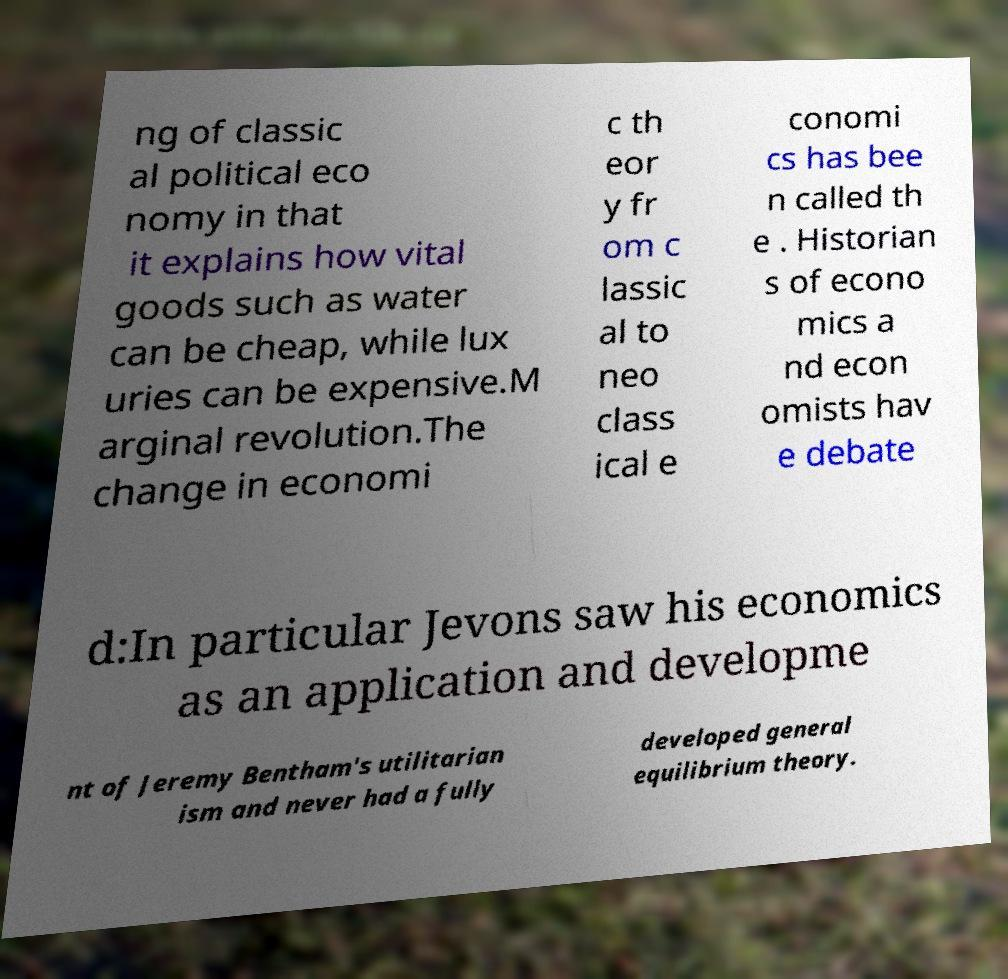Can you read and provide the text displayed in the image?This photo seems to have some interesting text. Can you extract and type it out for me? ng of classic al political eco nomy in that it explains how vital goods such as water can be cheap, while lux uries can be expensive.M arginal revolution.The change in economi c th eor y fr om c lassic al to neo class ical e conomi cs has bee n called th e . Historian s of econo mics a nd econ omists hav e debate d:In particular Jevons saw his economics as an application and developme nt of Jeremy Bentham's utilitarian ism and never had a fully developed general equilibrium theory. 